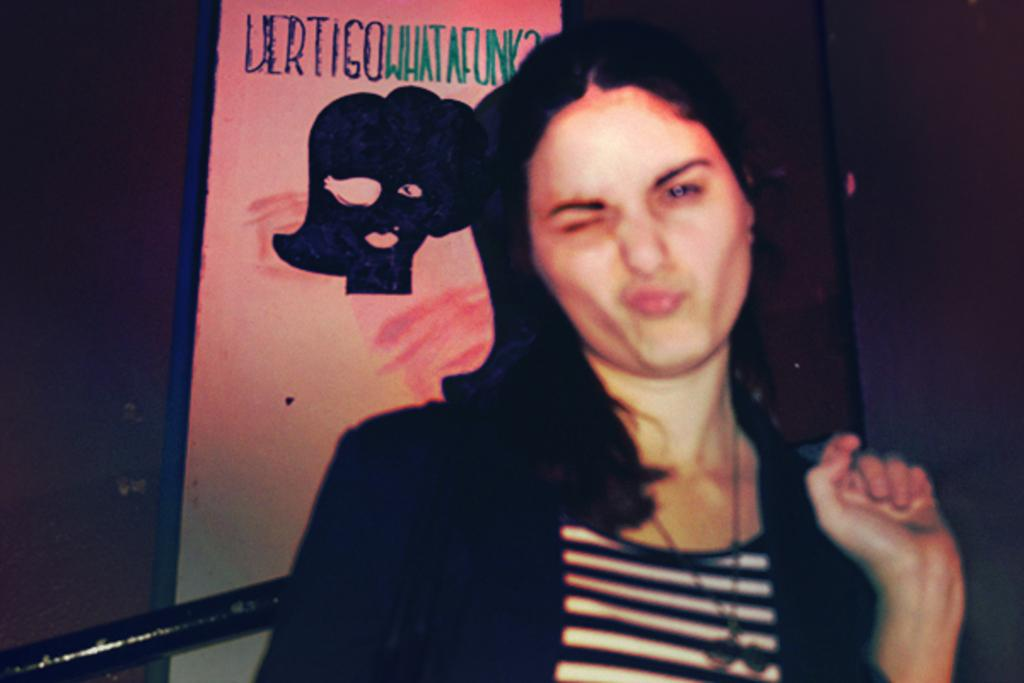Who is present in the image? There is a woman in the image. What can be seen on the wall in the background of the image? There is a board on the wall in the background of the image. How many tails can be seen on the woman in the image? There are no tails visible on the woman in the image. What type of waves can be seen crashing on the shore in the image? There is no shore or waves present in the image; it only features a woman and a board on the wall. 